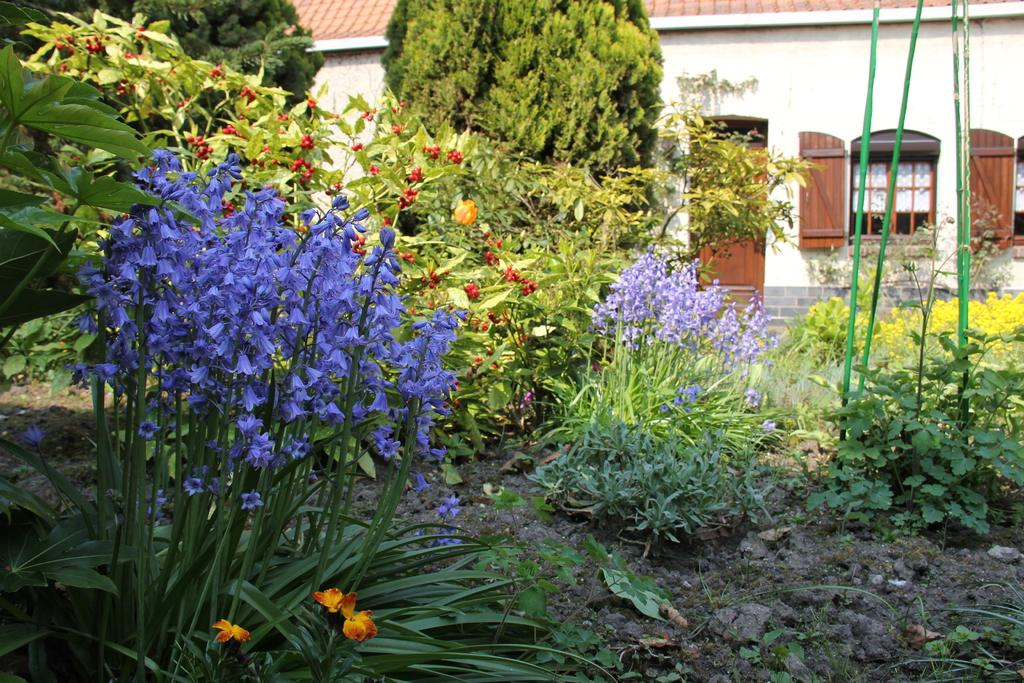What type of vegetation can be seen in the image? There are flowers, plants, and trees in the image. What architectural features are present in the image? There are windows and doors in the image. What type of building is visible in the image? There is a house in the image. What type of cracker is being used to build the house in the image? There is no cracker present in the image, and the house is not being built. Can you see any beetles crawling on the flowers in the image? There are no beetles visible in the image; only flowers, plants, trees, windows, doors, and a house can be seen. 